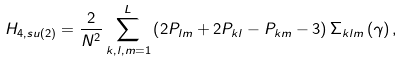Convert formula to latex. <formula><loc_0><loc_0><loc_500><loc_500>H _ { 4 , s u ( 2 ) } = \frac { 2 } { N ^ { 2 } } \sum _ { k , l , m = 1 } ^ { L } \left ( 2 P _ { l m } + 2 P _ { k l } - P _ { k m } - 3 \right ) \Sigma _ { k l m } \left ( \gamma \right ) ,</formula> 